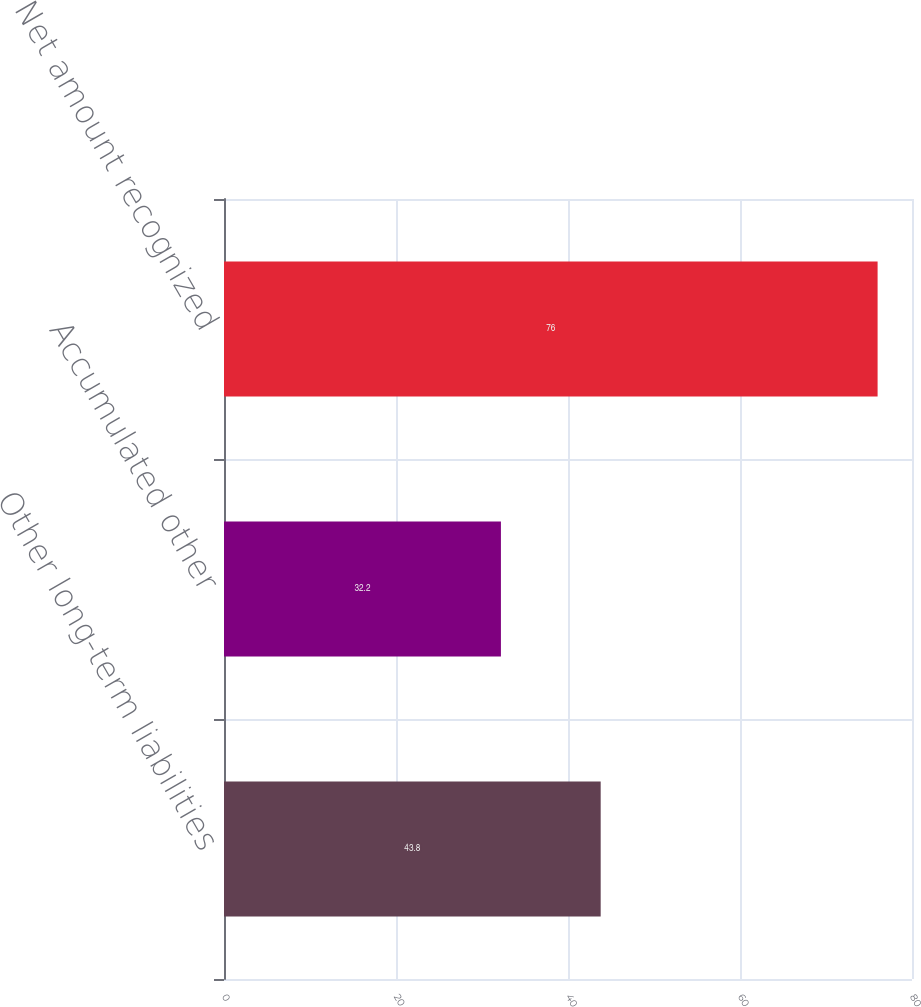<chart> <loc_0><loc_0><loc_500><loc_500><bar_chart><fcel>Other long-term liabilities<fcel>Accumulated other<fcel>Net amount recognized<nl><fcel>43.8<fcel>32.2<fcel>76<nl></chart> 